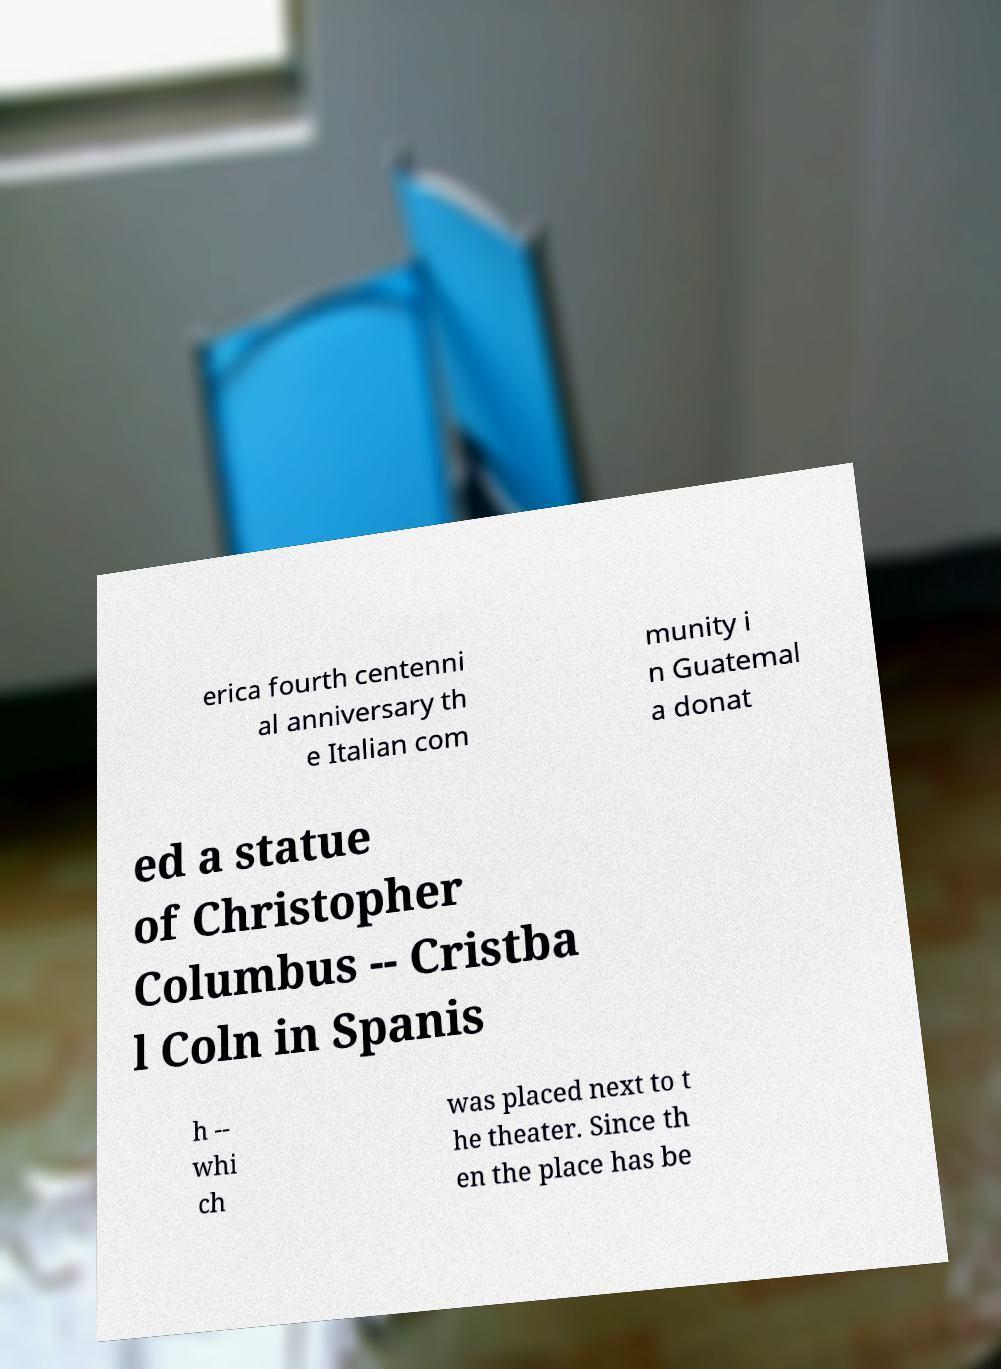Could you extract and type out the text from this image? erica fourth centenni al anniversary th e Italian com munity i n Guatemal a donat ed a statue of Christopher Columbus -- Cristba l Coln in Spanis h -- whi ch was placed next to t he theater. Since th en the place has be 